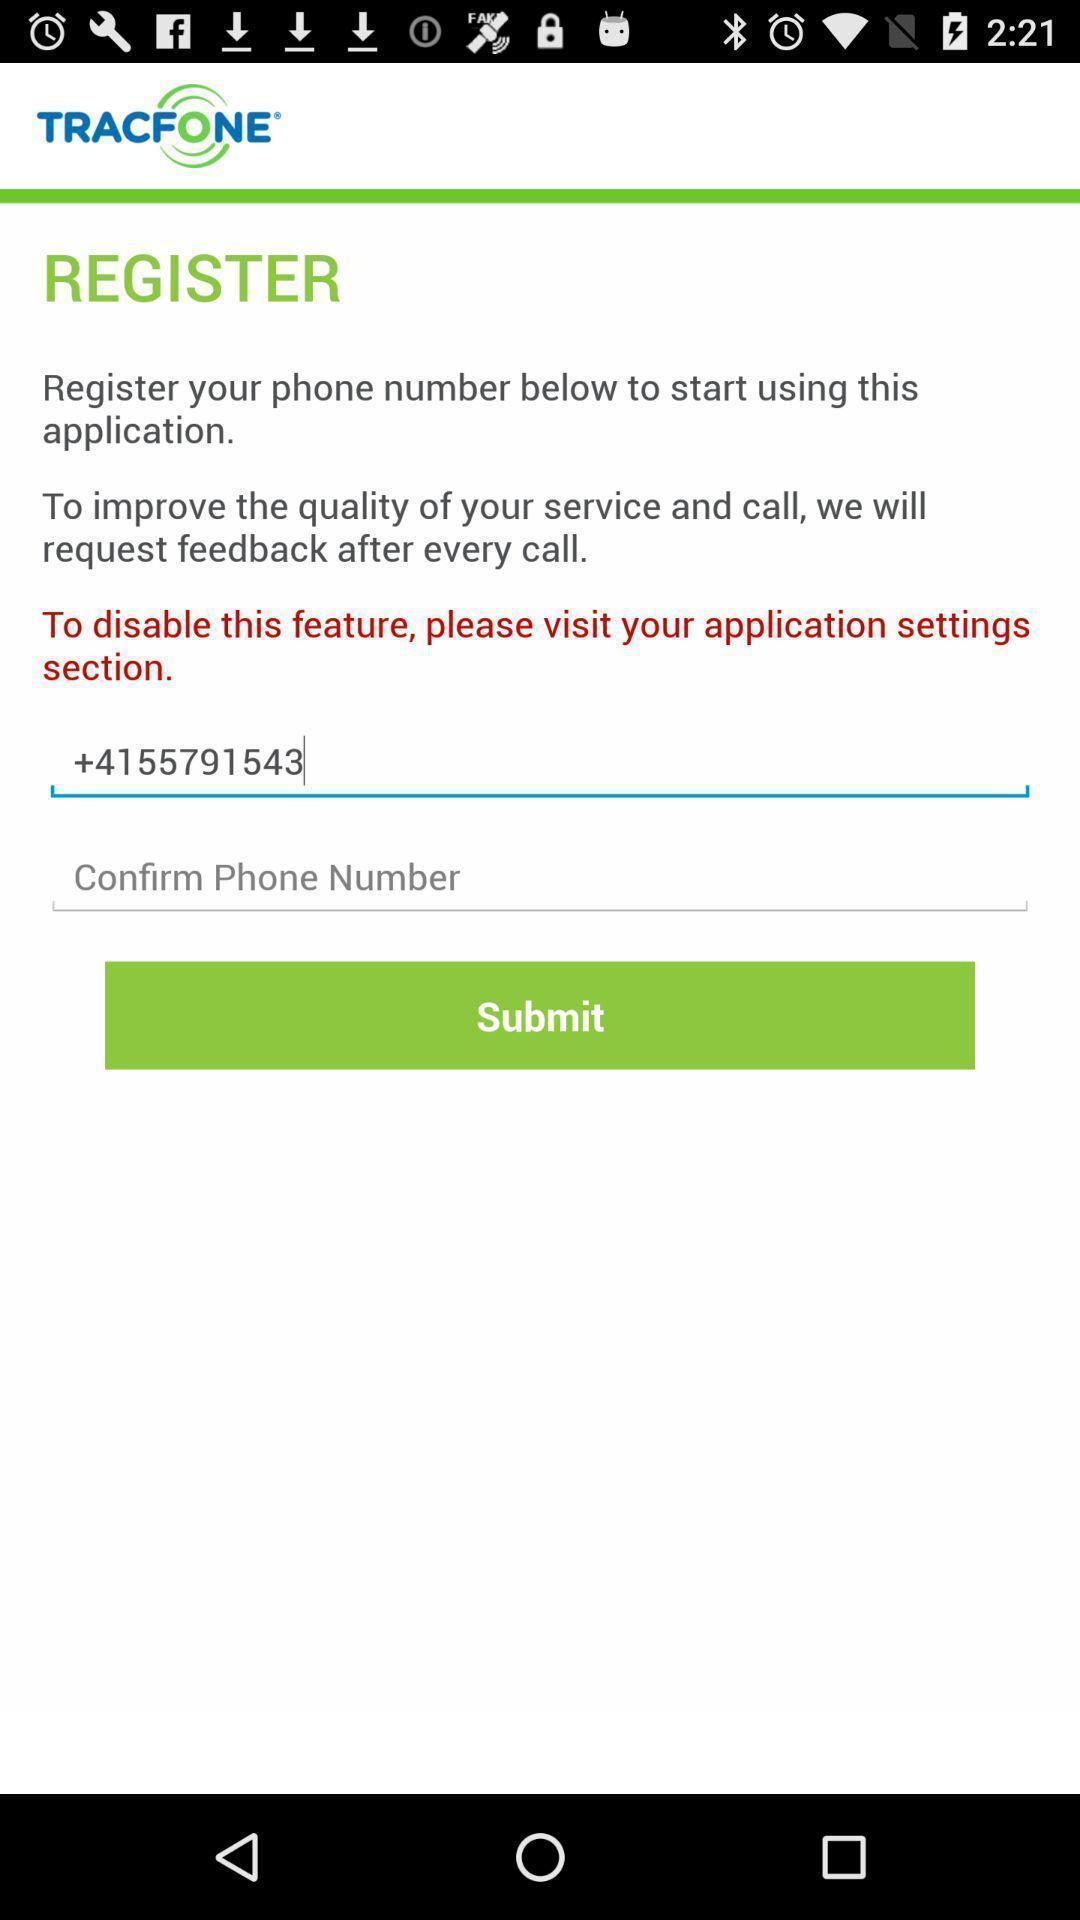Summarize the information in this screenshot. Screen showing register page. 